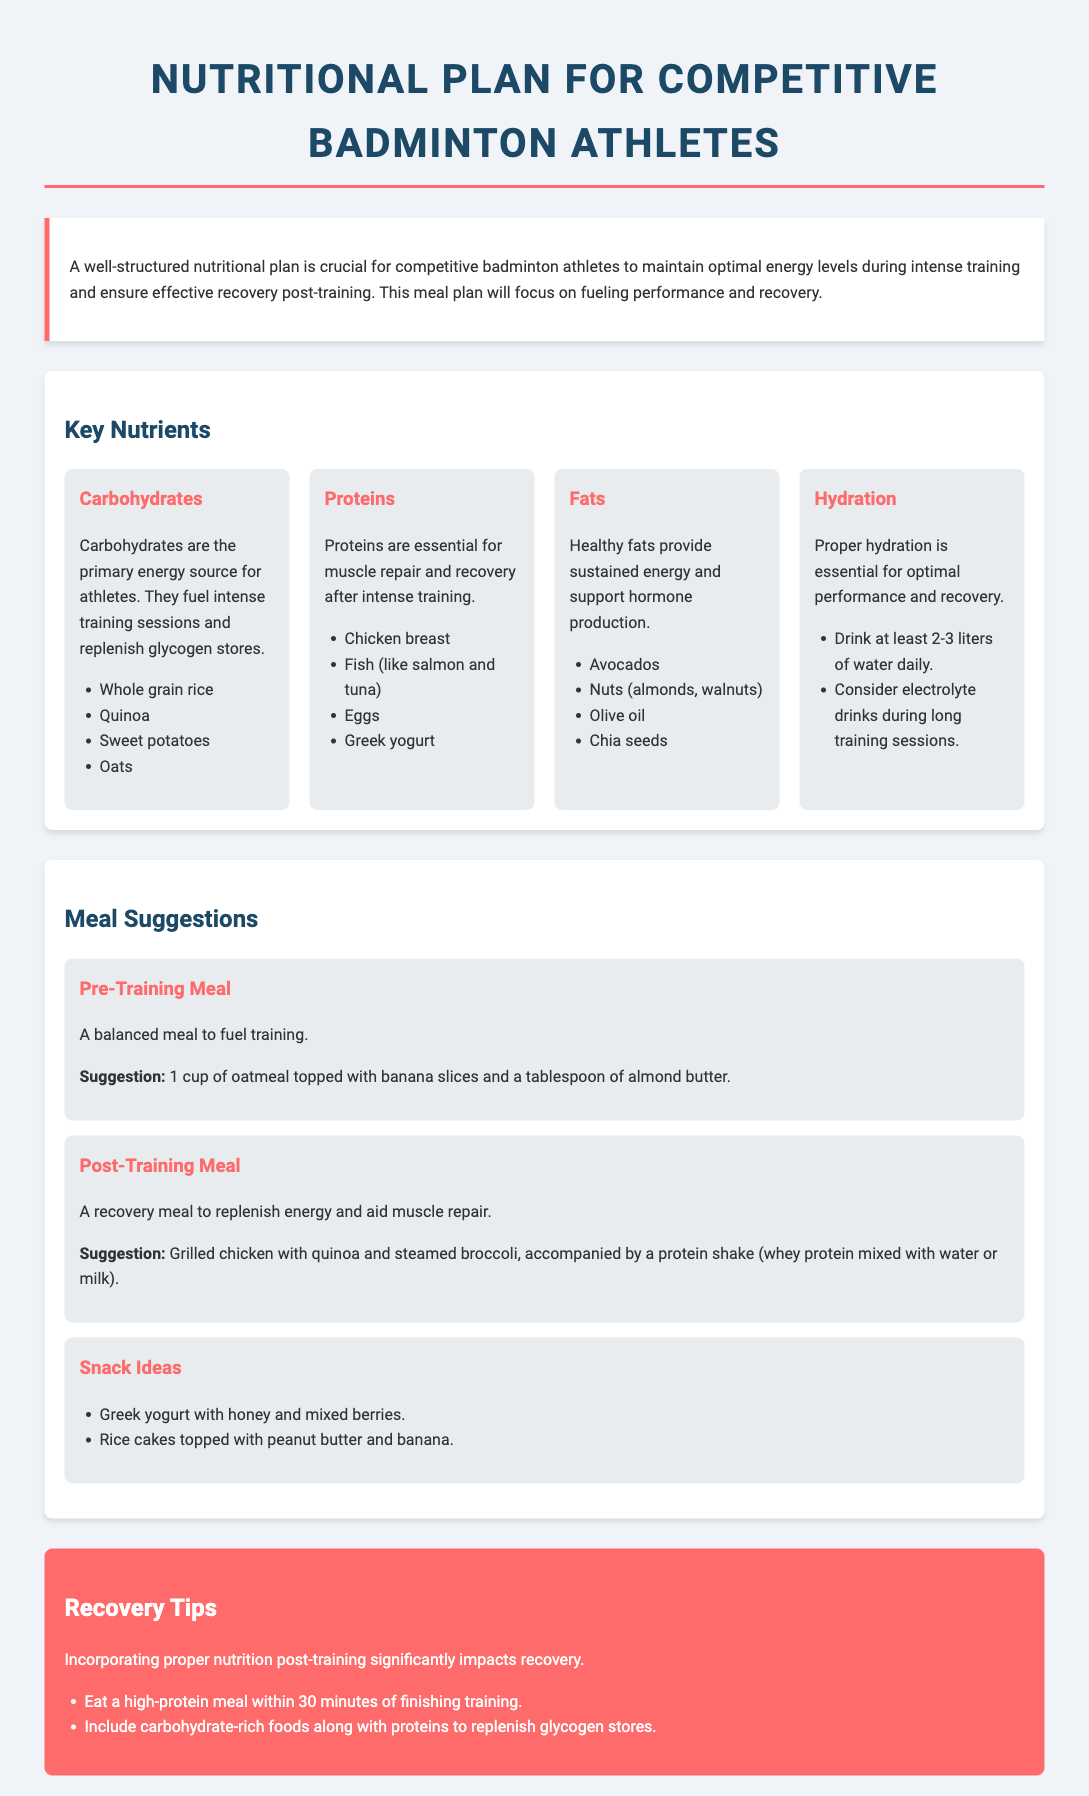What are the primary energy sources for athletes? The document states that carbohydrates are the primary energy source for athletes.
Answer: Carbohydrates What is a suggestion for a post-training meal? The document provides a specific suggestion for a post-training meal which includes grilled chicken with quinoa and steamed broccoli.
Answer: Grilled chicken with quinoa and steamed broccoli What is the recommended daily water intake? The document mentions that athletes should drink at least 2-3 liters of water daily.
Answer: 2-3 liters Which nutrient is essential for muscle repair? The document indicates that proteins are essential for muscle repair after intense training.
Answer: Proteins What should be consumed within 30 minutes of training? The document emphasizes the importance of eating a high-protein meal within 30 minutes of finishing training.
Answer: High-protein meal What are two examples of carbohydrate-rich foods? The document lists whole grain rice and sweet potatoes as examples of carbohydrate-rich foods.
Answer: Whole grain rice, sweet potatoes What is the focus of the nutritional plan? The document highlights that the focus of the nutritional plan is on fueling performance and recovery.
Answer: Fueling performance and recovery What type of fat is mentioned for sustained energy? The document refers to healthy fats as providing sustained energy.
Answer: Healthy fats 